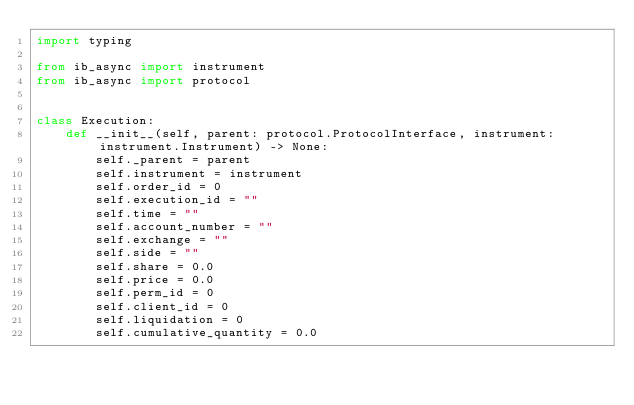<code> <loc_0><loc_0><loc_500><loc_500><_Python_>import typing

from ib_async import instrument
from ib_async import protocol


class Execution:
    def __init__(self, parent: protocol.ProtocolInterface, instrument: instrument.Instrument) -> None:
        self._parent = parent
        self.instrument = instrument
        self.order_id = 0
        self.execution_id = ""
        self.time = ""
        self.account_number = ""
        self.exchange = ""
        self.side = ""
        self.share = 0.0
        self.price = 0.0
        self.perm_id = 0
        self.client_id = 0
        self.liquidation = 0
        self.cumulative_quantity = 0.0</code> 